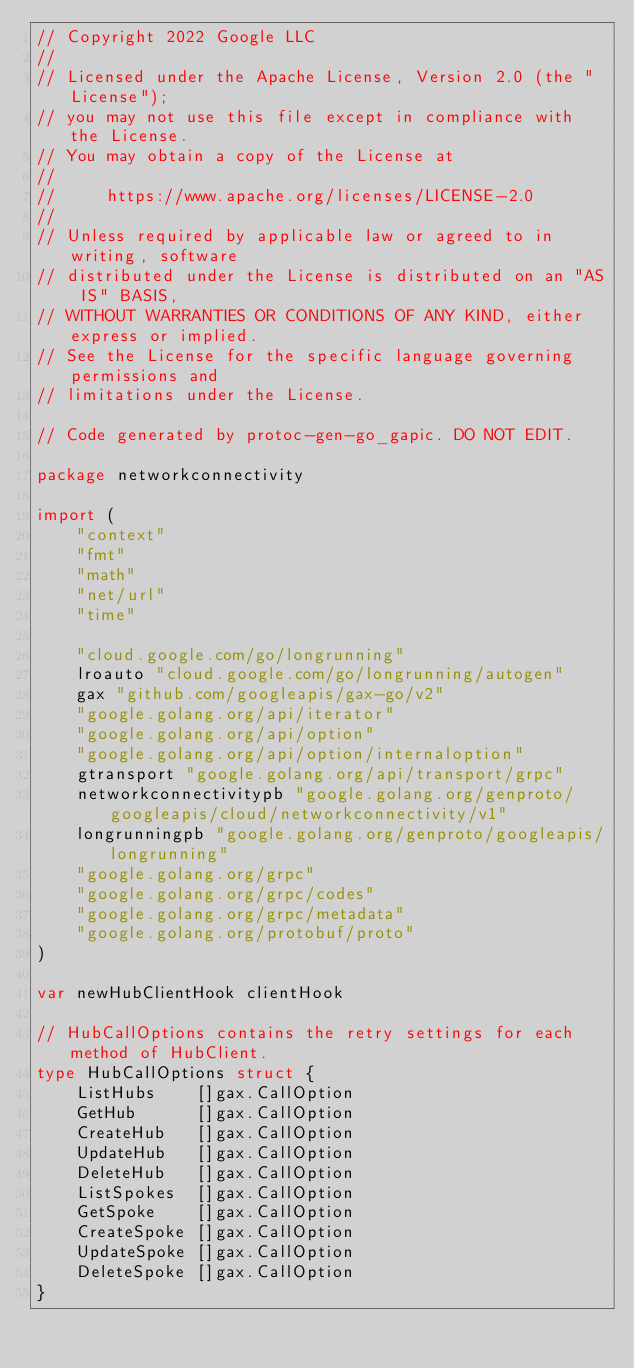Convert code to text. <code><loc_0><loc_0><loc_500><loc_500><_Go_>// Copyright 2022 Google LLC
//
// Licensed under the Apache License, Version 2.0 (the "License");
// you may not use this file except in compliance with the License.
// You may obtain a copy of the License at
//
//     https://www.apache.org/licenses/LICENSE-2.0
//
// Unless required by applicable law or agreed to in writing, software
// distributed under the License is distributed on an "AS IS" BASIS,
// WITHOUT WARRANTIES OR CONDITIONS OF ANY KIND, either express or implied.
// See the License for the specific language governing permissions and
// limitations under the License.

// Code generated by protoc-gen-go_gapic. DO NOT EDIT.

package networkconnectivity

import (
	"context"
	"fmt"
	"math"
	"net/url"
	"time"

	"cloud.google.com/go/longrunning"
	lroauto "cloud.google.com/go/longrunning/autogen"
	gax "github.com/googleapis/gax-go/v2"
	"google.golang.org/api/iterator"
	"google.golang.org/api/option"
	"google.golang.org/api/option/internaloption"
	gtransport "google.golang.org/api/transport/grpc"
	networkconnectivitypb "google.golang.org/genproto/googleapis/cloud/networkconnectivity/v1"
	longrunningpb "google.golang.org/genproto/googleapis/longrunning"
	"google.golang.org/grpc"
	"google.golang.org/grpc/codes"
	"google.golang.org/grpc/metadata"
	"google.golang.org/protobuf/proto"
)

var newHubClientHook clientHook

// HubCallOptions contains the retry settings for each method of HubClient.
type HubCallOptions struct {
	ListHubs    []gax.CallOption
	GetHub      []gax.CallOption
	CreateHub   []gax.CallOption
	UpdateHub   []gax.CallOption
	DeleteHub   []gax.CallOption
	ListSpokes  []gax.CallOption
	GetSpoke    []gax.CallOption
	CreateSpoke []gax.CallOption
	UpdateSpoke []gax.CallOption
	DeleteSpoke []gax.CallOption
}
</code> 